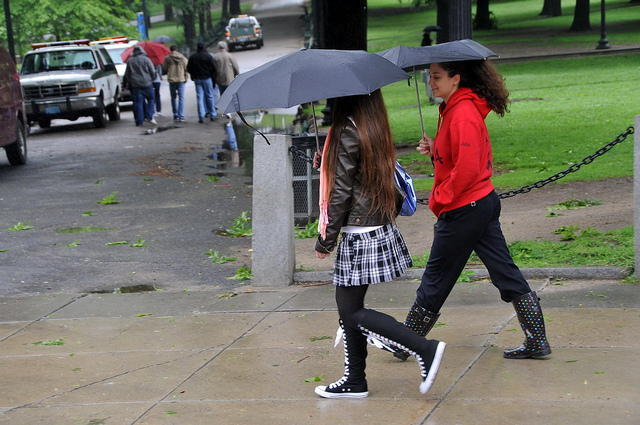<image>What to the white lines depict? I don't know what the white lines depict. They could be cracks, lanes, or shoelaces. What pattern is the skirt? I am not sure about the pattern of the skirt. It can be either plaid or checkered. What to the white lines depict? The white lines can depict either cracks or shoelaces. What pattern is the skirt? The skirt has a plaid pattern. 